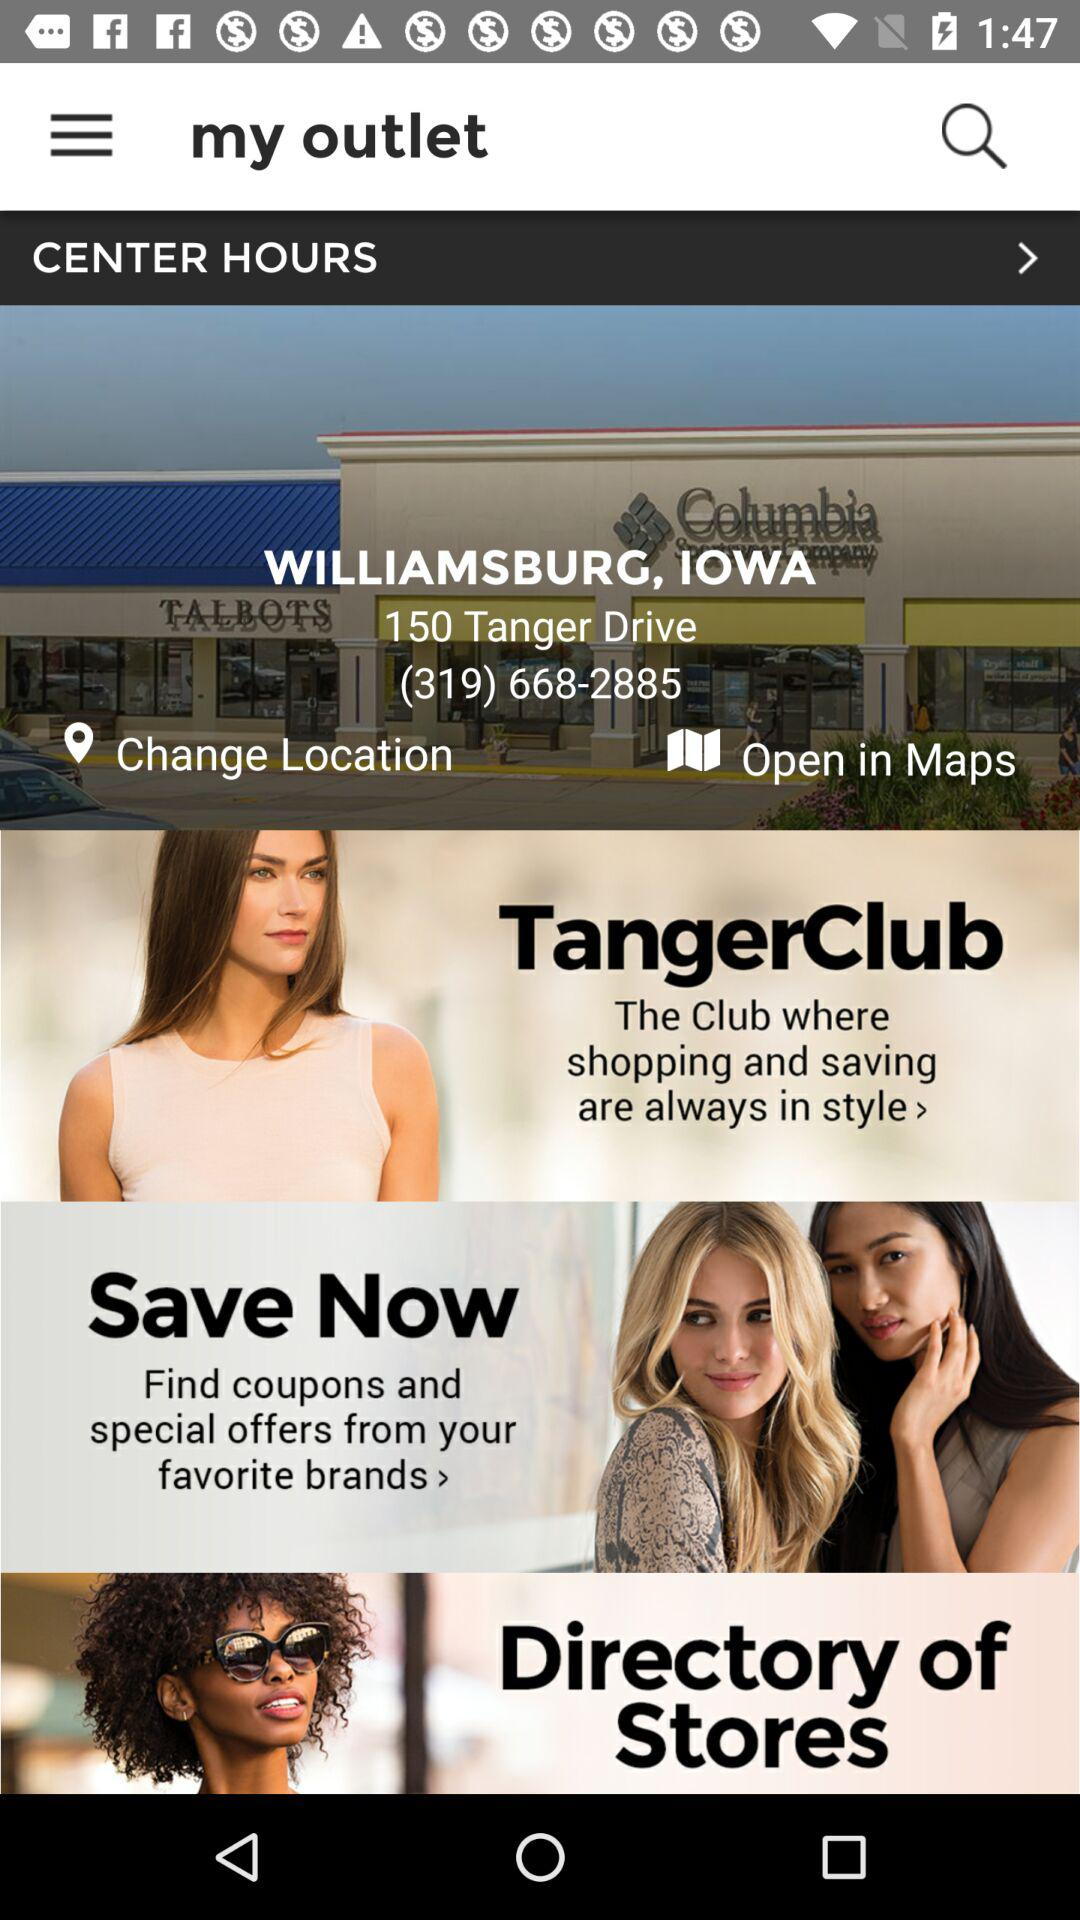What is the phone number? The phone number is (319) 668-2885. 